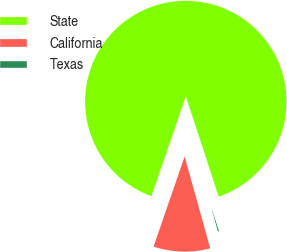Convert chart. <chart><loc_0><loc_0><loc_500><loc_500><pie_chart><fcel>State<fcel>California<fcel>Texas<nl><fcel>89.68%<fcel>9.61%<fcel>0.71%<nl></chart> 